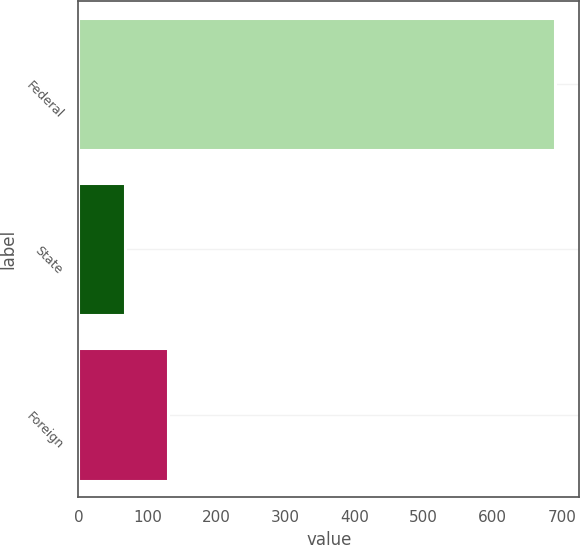<chart> <loc_0><loc_0><loc_500><loc_500><bar_chart><fcel>Federal<fcel>State<fcel>Foreign<nl><fcel>691<fcel>68<fcel>130.3<nl></chart> 